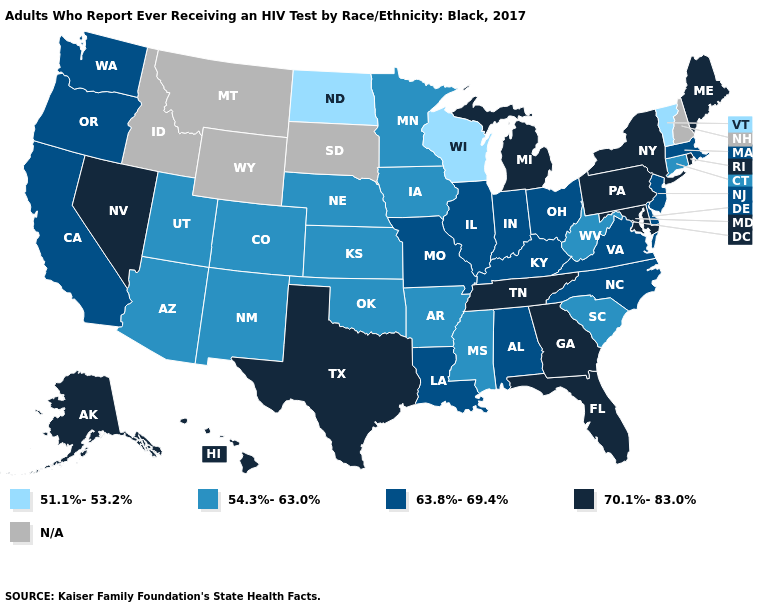Does Florida have the highest value in the South?
Short answer required. Yes. Name the states that have a value in the range N/A?
Short answer required. Idaho, Montana, New Hampshire, South Dakota, Wyoming. Name the states that have a value in the range 54.3%-63.0%?
Short answer required. Arizona, Arkansas, Colorado, Connecticut, Iowa, Kansas, Minnesota, Mississippi, Nebraska, New Mexico, Oklahoma, South Carolina, Utah, West Virginia. Among the states that border New York , which have the lowest value?
Quick response, please. Vermont. Among the states that border Vermont , which have the highest value?
Be succinct. New York. Name the states that have a value in the range 70.1%-83.0%?
Quick response, please. Alaska, Florida, Georgia, Hawaii, Maine, Maryland, Michigan, Nevada, New York, Pennsylvania, Rhode Island, Tennessee, Texas. What is the value of Hawaii?
Give a very brief answer. 70.1%-83.0%. Does Hawaii have the highest value in the West?
Be succinct. Yes. Name the states that have a value in the range 70.1%-83.0%?
Write a very short answer. Alaska, Florida, Georgia, Hawaii, Maine, Maryland, Michigan, Nevada, New York, Pennsylvania, Rhode Island, Tennessee, Texas. Among the states that border Mississippi , which have the highest value?
Answer briefly. Tennessee. Name the states that have a value in the range N/A?
Quick response, please. Idaho, Montana, New Hampshire, South Dakota, Wyoming. 